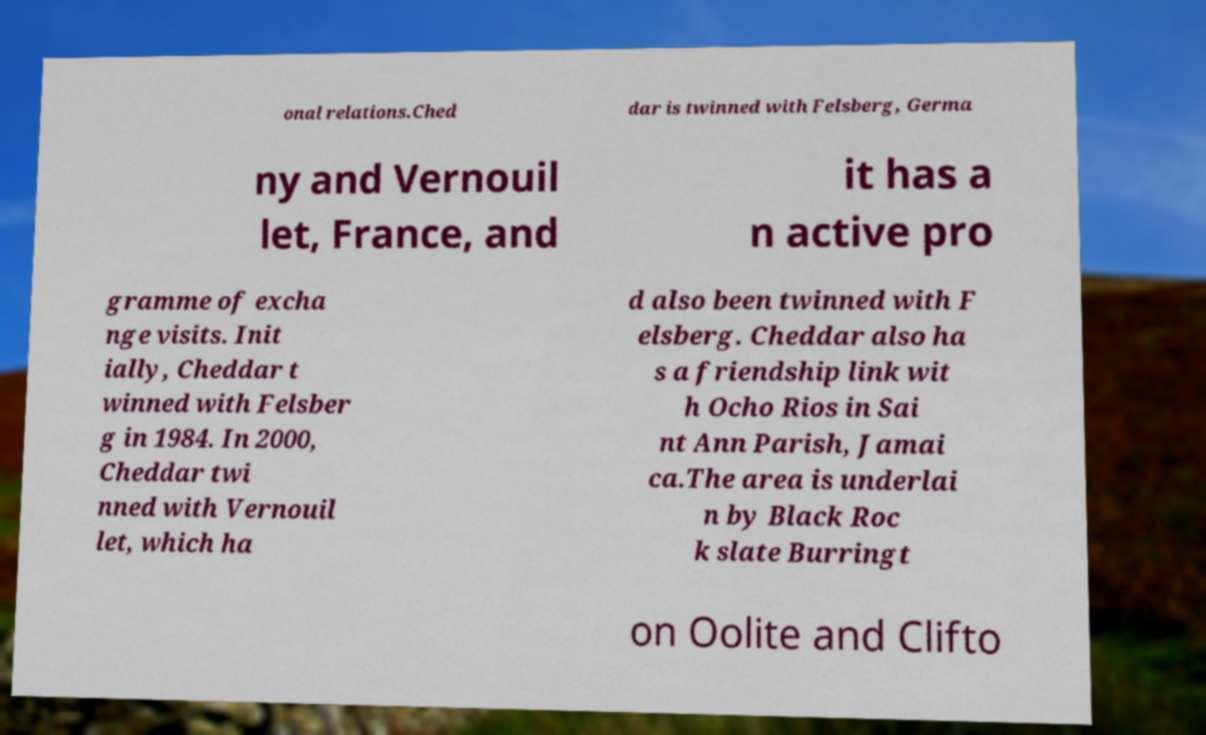Can you accurately transcribe the text from the provided image for me? onal relations.Ched dar is twinned with Felsberg, Germa ny and Vernouil let, France, and it has a n active pro gramme of excha nge visits. Init ially, Cheddar t winned with Felsber g in 1984. In 2000, Cheddar twi nned with Vernouil let, which ha d also been twinned with F elsberg. Cheddar also ha s a friendship link wit h Ocho Rios in Sai nt Ann Parish, Jamai ca.The area is underlai n by Black Roc k slate Burringt on Oolite and Clifto 